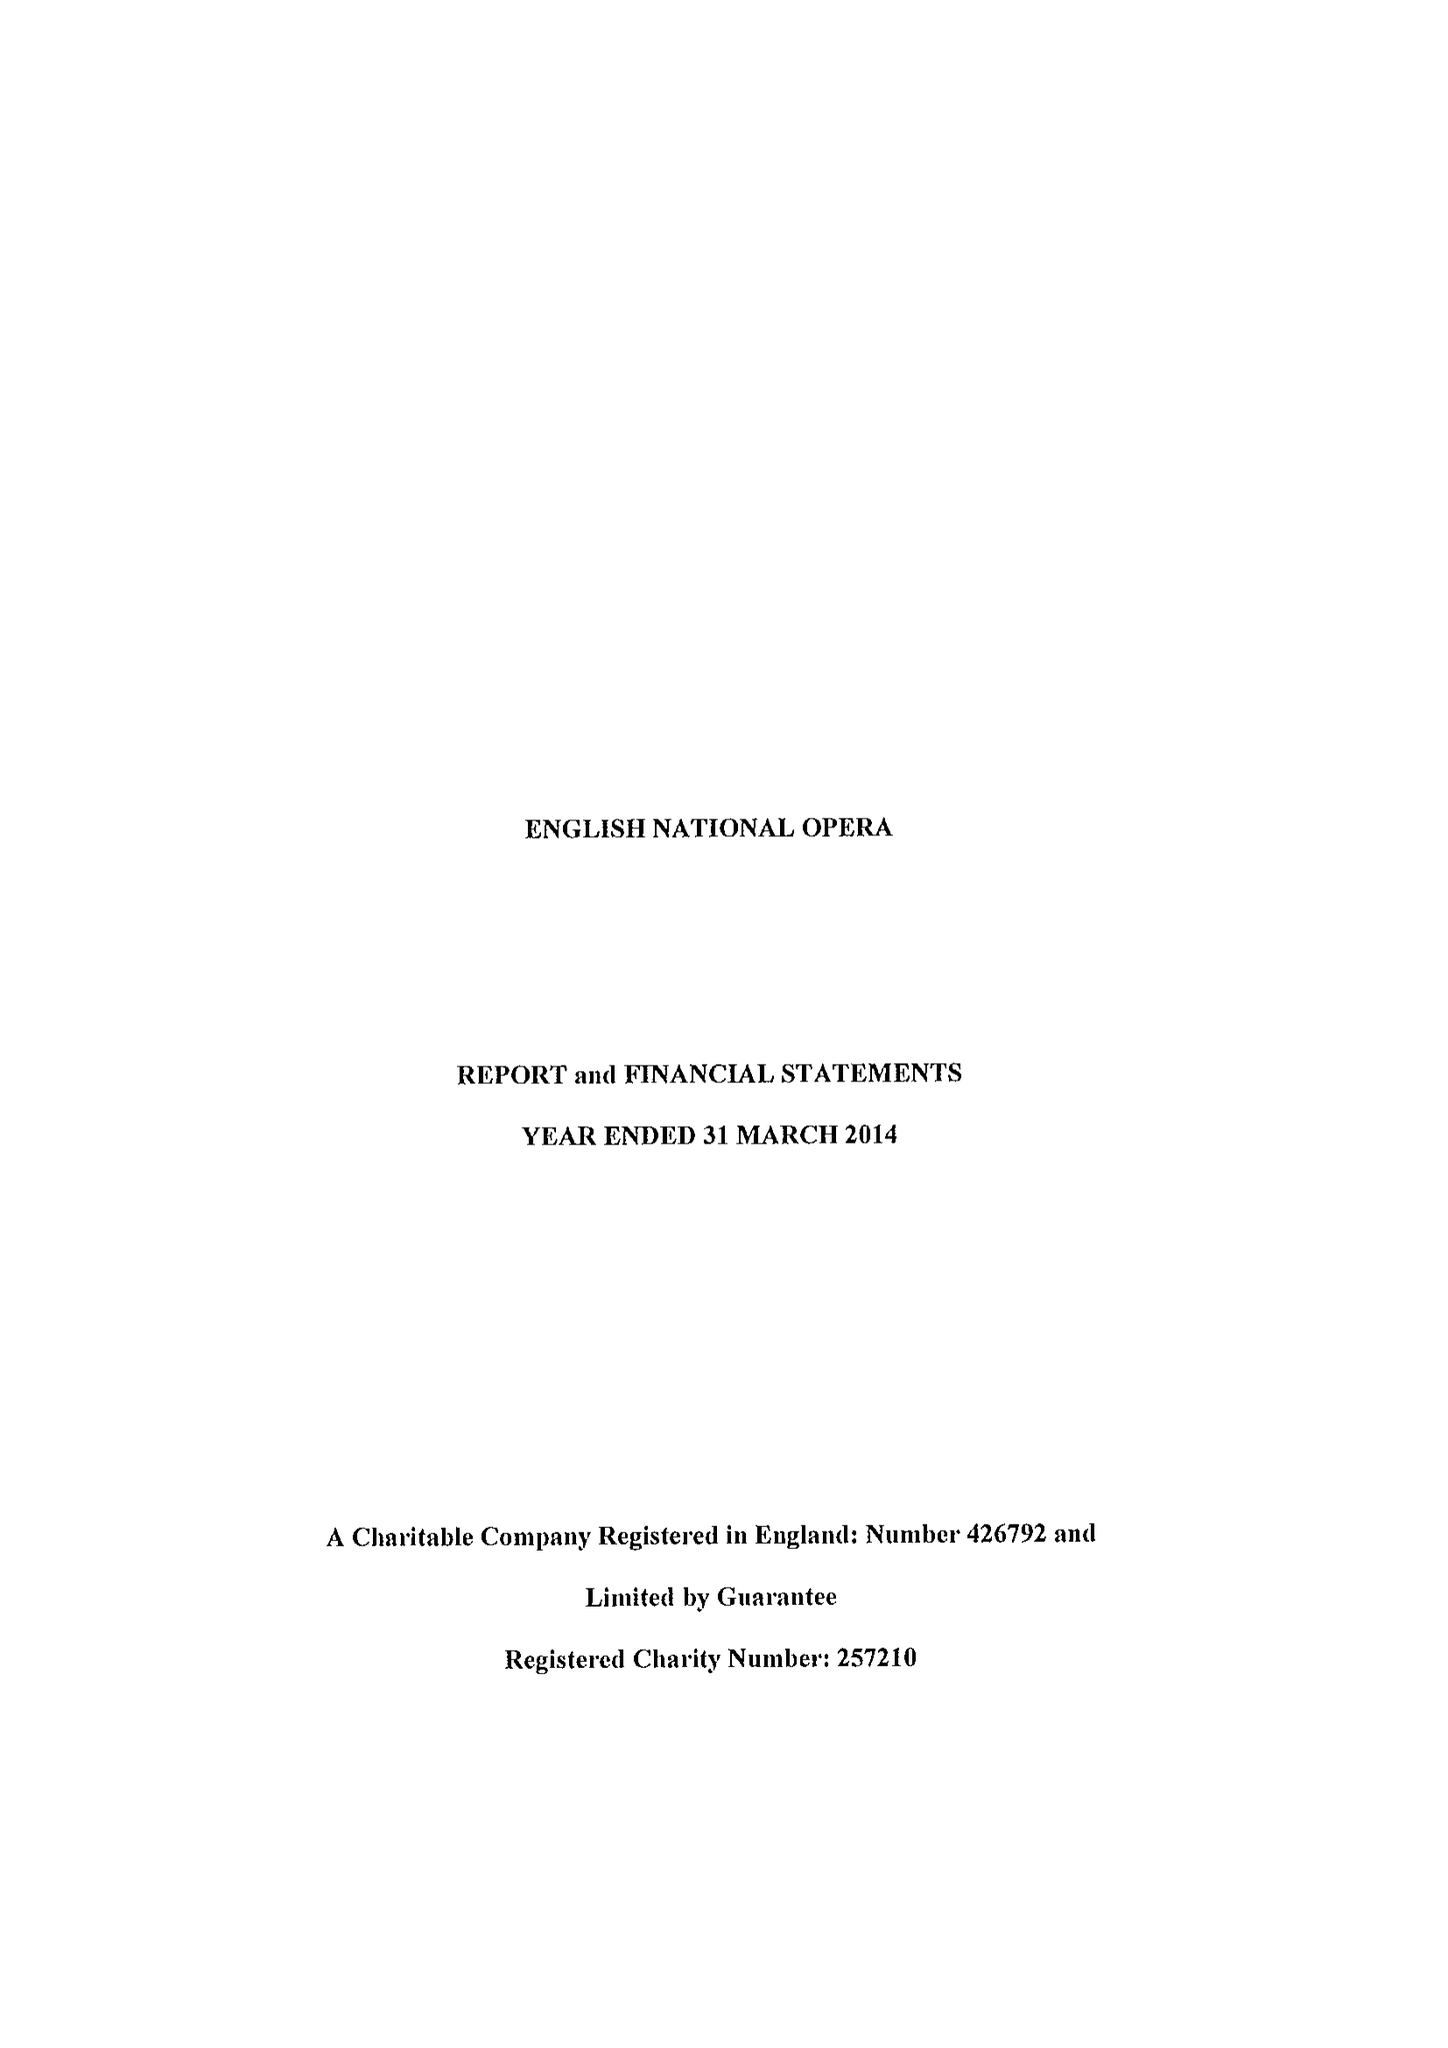What is the value for the address__postcode?
Answer the question using a single word or phrase. WC2R 4ES 